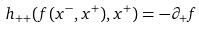<formula> <loc_0><loc_0><loc_500><loc_500>h _ { + + } ( f ( x ^ { - } , x ^ { + } ) , x ^ { + } ) = - \partial _ { + } f</formula> 